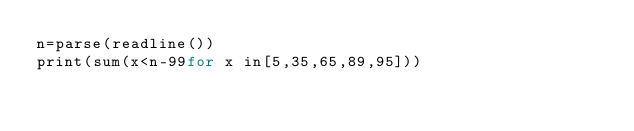<code> <loc_0><loc_0><loc_500><loc_500><_Julia_>n=parse(readline())
print(sum(x<n-99for x in[5,35,65,89,95]))</code> 